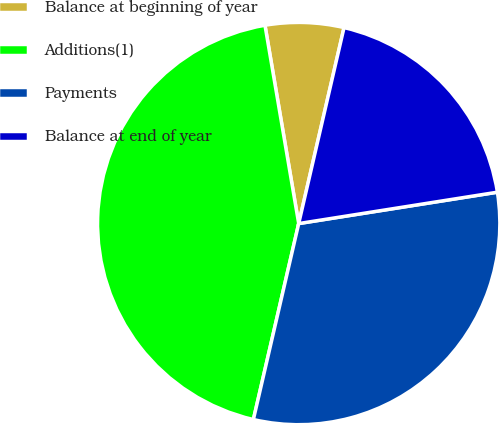Convert chart to OTSL. <chart><loc_0><loc_0><loc_500><loc_500><pie_chart><fcel>Balance at beginning of year<fcel>Additions(1)<fcel>Payments<fcel>Balance at end of year<nl><fcel>6.3%<fcel>43.7%<fcel>31.11%<fcel>18.89%<nl></chart> 